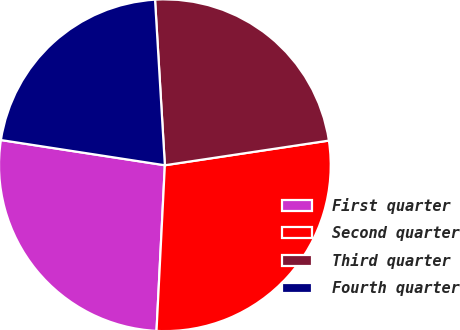Convert chart to OTSL. <chart><loc_0><loc_0><loc_500><loc_500><pie_chart><fcel>First quarter<fcel>Second quarter<fcel>Third quarter<fcel>Fourth quarter<nl><fcel>26.63%<fcel>28.18%<fcel>23.57%<fcel>21.63%<nl></chart> 